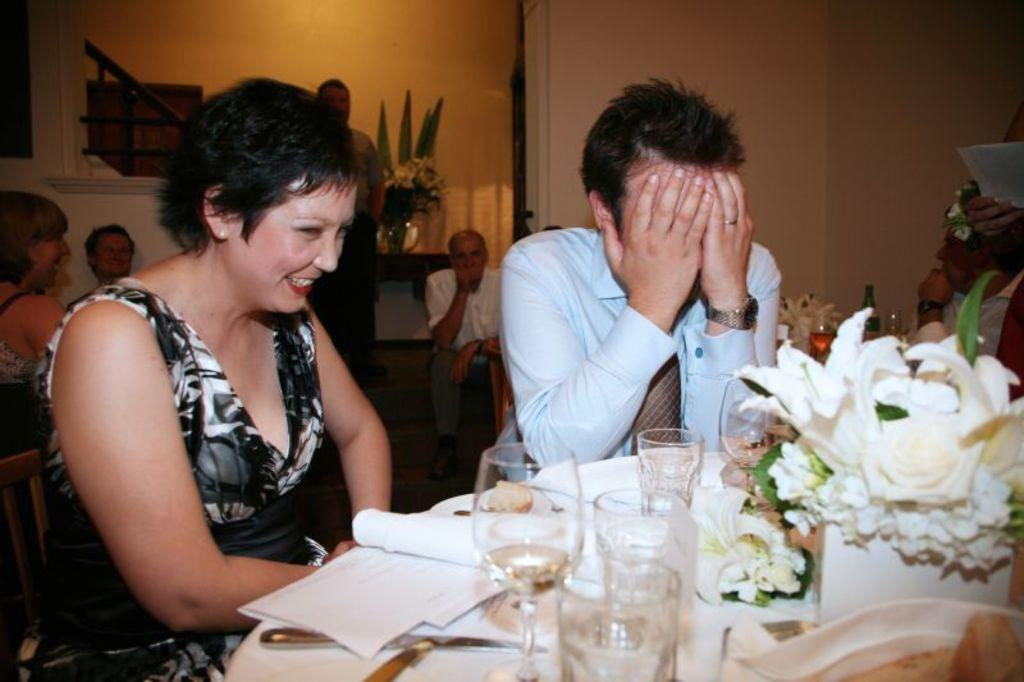Who or what can be seen in the image? There are people in the image. What else is present in the image besides the people? There are objects on a table in the image. What type of head can be seen on the table in the image? There is no head present on the table in the image. What type of cup can be seen in the image? The provided facts do not mention a cup being present in the image. 